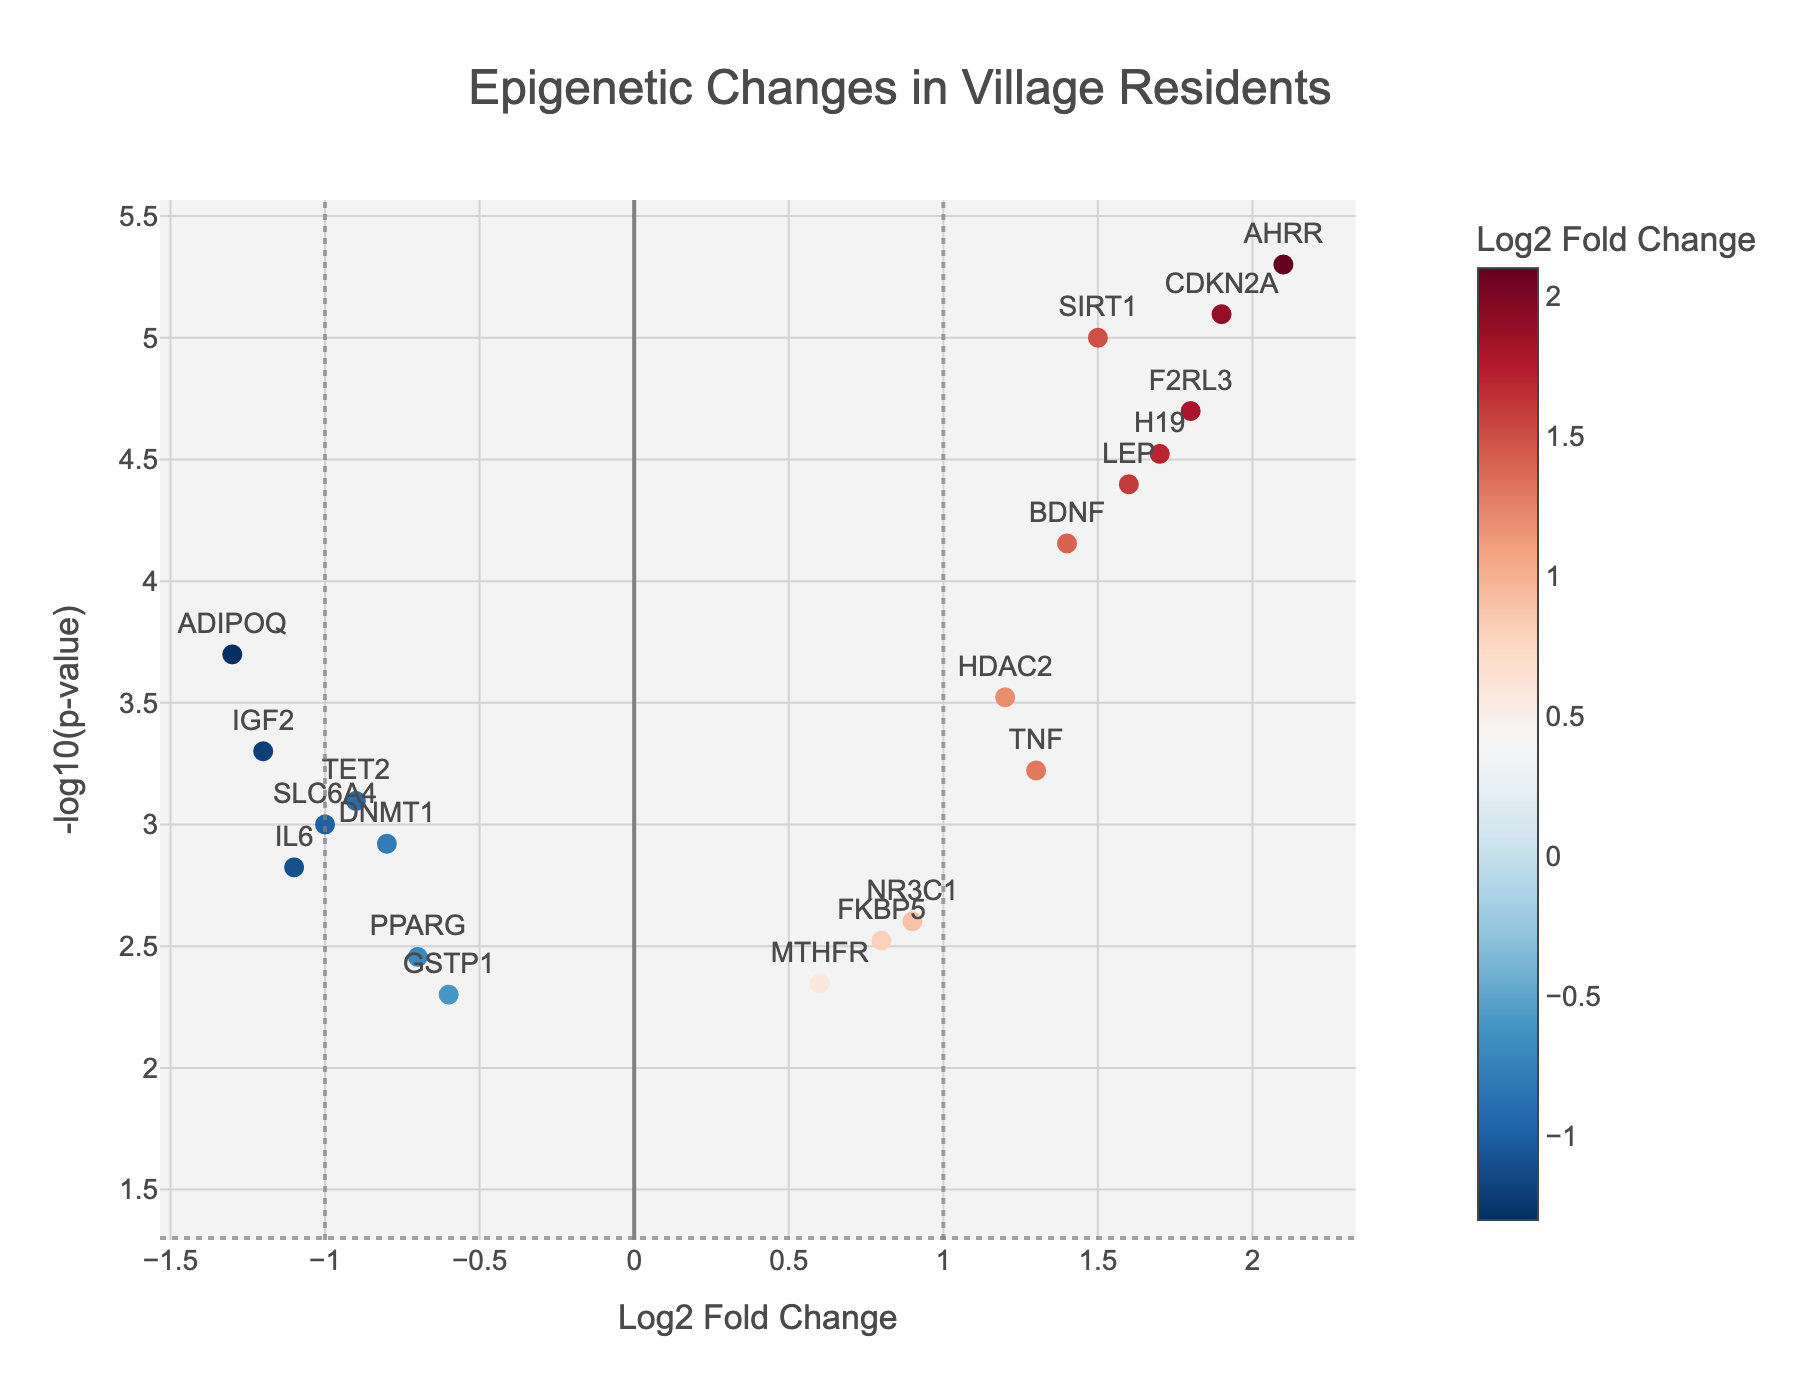What's the title of the figure? The title is located at the top of the plot, often in a larger and bold font. It summarizes the main subject of the visual representation.
Answer: Epigenetic Changes in Village Residents Which axis represents the Log2 Fold Change? The axis labels provide a description of the data plotted along each axis. The Log2 Fold Change is indicated on the horizontal axis in the figure.
Answer: Horizontal axis How many genes have a Log2 Fold Change greater than 1? To determine this, count the points located to the right of the vertical line at x=1 on the plot. These represent genes with a Log2 Fold Change greater than 1.
Answer: 7 What is the most significant gene in terms of p-value? The significance is indicated by the -log10(p-value), which is higher for more significant p-values. Look for the highest point on the y-axis.
Answer: SIRT1 Which gene showed the greatest decrease in expression? The gene with the most negative Log2 Fold Change has the greatest decrease in expression. Look for the point farthest to the left on the x-axis.
Answer: ADIPOQ Are there any genes with a -log10(p-value) less than 1? This can be checked by looking for any points below the horizontal line at y=1, which corresponds to a p-value of 0.1.
Answer: No Which gene has both a positive Log2 Fold Change and a -log10(p-value) above 4? Identify points to the right of the vertical line at x=0 (positive Log2 Fold Change) and above the horizontal line at y=4.
Answer: LEP Compare the Log2 Fold Change of TNF and H19. Which is higher? Locate the points for TNF and H19 on the plot and compare their horizontal positions. The point farther to the right has the higher Log2 Fold Change.
Answer: H19 Calculate the average of the -log10(p-value) for genes with a Log2 Fold Change less than -1. Identify the points to the left of the vertical line at x=-1, then find the average of their y-axis values.
Answer: (2.82 + 3.00 + 3.30) / 3 = 3.04 Which genes are below the threshold of -log10(p-value) = 2? Only consider points below the horizontal line at y=2, indicating a p-value greater than 0.01.
Answer: GSTP1, MTHFR 